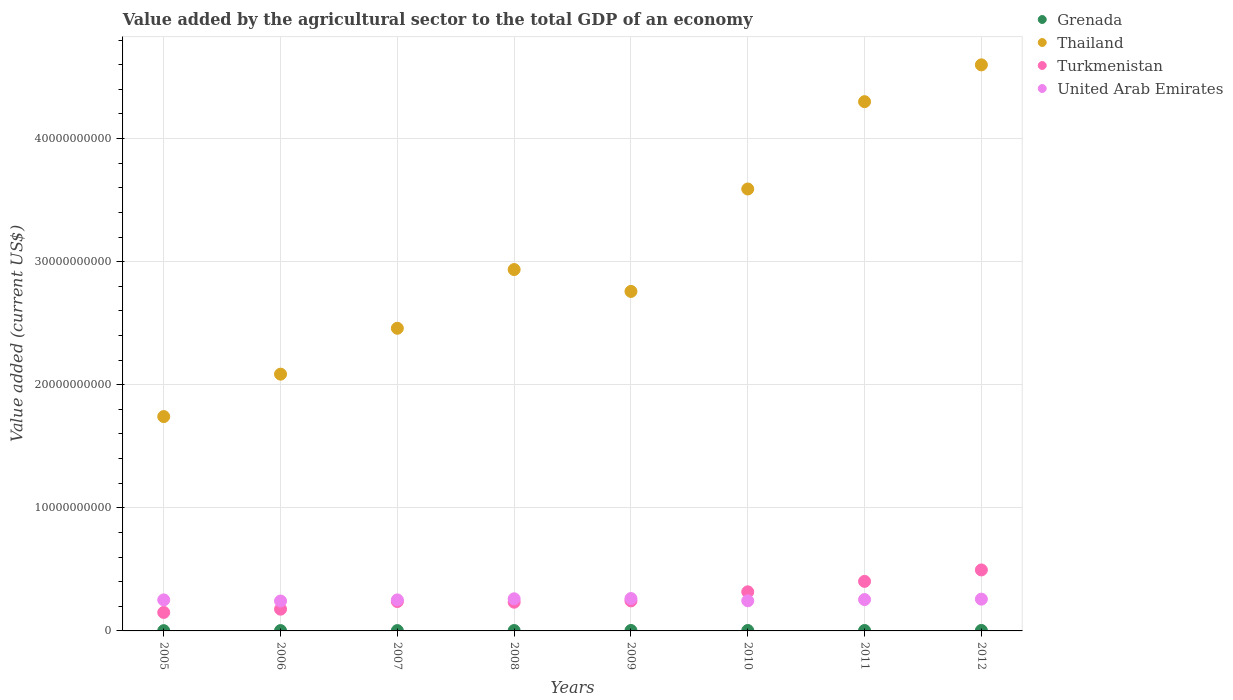How many different coloured dotlines are there?
Offer a terse response. 4. What is the value added by the agricultural sector to the total GDP in Turkmenistan in 2012?
Your answer should be compact. 4.95e+09. Across all years, what is the maximum value added by the agricultural sector to the total GDP in Thailand?
Offer a very short reply. 4.60e+1. Across all years, what is the minimum value added by the agricultural sector to the total GDP in Thailand?
Your answer should be very brief. 1.74e+1. In which year was the value added by the agricultural sector to the total GDP in Grenada minimum?
Make the answer very short. 2005. What is the total value added by the agricultural sector to the total GDP in Grenada in the graph?
Provide a short and direct response. 2.50e+08. What is the difference between the value added by the agricultural sector to the total GDP in Thailand in 2007 and that in 2010?
Give a very brief answer. -1.13e+1. What is the difference between the value added by the agricultural sector to the total GDP in United Arab Emirates in 2009 and the value added by the agricultural sector to the total GDP in Thailand in 2012?
Keep it short and to the point. -4.34e+1. What is the average value added by the agricultural sector to the total GDP in Grenada per year?
Ensure brevity in your answer.  3.12e+07. In the year 2008, what is the difference between the value added by the agricultural sector to the total GDP in Thailand and value added by the agricultural sector to the total GDP in Grenada?
Make the answer very short. 2.93e+1. In how many years, is the value added by the agricultural sector to the total GDP in Thailand greater than 16000000000 US$?
Your answer should be very brief. 8. What is the ratio of the value added by the agricultural sector to the total GDP in Thailand in 2006 to that in 2012?
Keep it short and to the point. 0.45. Is the value added by the agricultural sector to the total GDP in Turkmenistan in 2010 less than that in 2011?
Ensure brevity in your answer.  Yes. What is the difference between the highest and the second highest value added by the agricultural sector to the total GDP in Thailand?
Offer a very short reply. 2.99e+09. What is the difference between the highest and the lowest value added by the agricultural sector to the total GDP in United Arab Emirates?
Your response must be concise. 1.99e+08. In how many years, is the value added by the agricultural sector to the total GDP in Thailand greater than the average value added by the agricultural sector to the total GDP in Thailand taken over all years?
Provide a short and direct response. 3. Is it the case that in every year, the sum of the value added by the agricultural sector to the total GDP in Thailand and value added by the agricultural sector to the total GDP in Grenada  is greater than the value added by the agricultural sector to the total GDP in United Arab Emirates?
Give a very brief answer. Yes. Does the value added by the agricultural sector to the total GDP in United Arab Emirates monotonically increase over the years?
Your response must be concise. No. Is the value added by the agricultural sector to the total GDP in United Arab Emirates strictly less than the value added by the agricultural sector to the total GDP in Turkmenistan over the years?
Make the answer very short. No. How many dotlines are there?
Provide a short and direct response. 4. How many years are there in the graph?
Keep it short and to the point. 8. Are the values on the major ticks of Y-axis written in scientific E-notation?
Offer a very short reply. No. Does the graph contain any zero values?
Offer a very short reply. No. Where does the legend appear in the graph?
Provide a succinct answer. Top right. What is the title of the graph?
Your answer should be compact. Value added by the agricultural sector to the total GDP of an economy. Does "Tuvalu" appear as one of the legend labels in the graph?
Give a very brief answer. No. What is the label or title of the X-axis?
Ensure brevity in your answer.  Years. What is the label or title of the Y-axis?
Your answer should be very brief. Value added (current US$). What is the Value added (current US$) in Grenada in 2005?
Your answer should be very brief. 2.06e+07. What is the Value added (current US$) in Thailand in 2005?
Make the answer very short. 1.74e+1. What is the Value added (current US$) of Turkmenistan in 2005?
Your answer should be very brief. 1.50e+09. What is the Value added (current US$) in United Arab Emirates in 2005?
Keep it short and to the point. 2.52e+09. What is the Value added (current US$) of Grenada in 2006?
Make the answer very short. 2.72e+07. What is the Value added (current US$) in Thailand in 2006?
Make the answer very short. 2.09e+1. What is the Value added (current US$) of Turkmenistan in 2006?
Your answer should be very brief. 1.77e+09. What is the Value added (current US$) of United Arab Emirates in 2006?
Offer a very short reply. 2.43e+09. What is the Value added (current US$) of Grenada in 2007?
Your response must be concise. 2.70e+07. What is the Value added (current US$) in Thailand in 2007?
Ensure brevity in your answer.  2.46e+1. What is the Value added (current US$) in Turkmenistan in 2007?
Offer a very short reply. 2.39e+09. What is the Value added (current US$) of United Arab Emirates in 2007?
Make the answer very short. 2.52e+09. What is the Value added (current US$) in Grenada in 2008?
Offer a very short reply. 3.11e+07. What is the Value added (current US$) of Thailand in 2008?
Your answer should be very brief. 2.94e+1. What is the Value added (current US$) in Turkmenistan in 2008?
Give a very brief answer. 2.33e+09. What is the Value added (current US$) of United Arab Emirates in 2008?
Ensure brevity in your answer.  2.61e+09. What is the Value added (current US$) of Grenada in 2009?
Provide a short and direct response. 3.57e+07. What is the Value added (current US$) in Thailand in 2009?
Ensure brevity in your answer.  2.76e+1. What is the Value added (current US$) in Turkmenistan in 2009?
Provide a succinct answer. 2.44e+09. What is the Value added (current US$) of United Arab Emirates in 2009?
Your response must be concise. 2.63e+09. What is the Value added (current US$) of Grenada in 2010?
Ensure brevity in your answer.  3.48e+07. What is the Value added (current US$) in Thailand in 2010?
Make the answer very short. 3.59e+1. What is the Value added (current US$) in Turkmenistan in 2010?
Ensure brevity in your answer.  3.18e+09. What is the Value added (current US$) of United Arab Emirates in 2010?
Your answer should be compact. 2.45e+09. What is the Value added (current US$) in Grenada in 2011?
Ensure brevity in your answer.  3.46e+07. What is the Value added (current US$) in Thailand in 2011?
Keep it short and to the point. 4.30e+1. What is the Value added (current US$) of Turkmenistan in 2011?
Offer a terse response. 4.03e+09. What is the Value added (current US$) in United Arab Emirates in 2011?
Ensure brevity in your answer.  2.55e+09. What is the Value added (current US$) in Grenada in 2012?
Give a very brief answer. 3.87e+07. What is the Value added (current US$) of Thailand in 2012?
Provide a short and direct response. 4.60e+1. What is the Value added (current US$) of Turkmenistan in 2012?
Your answer should be very brief. 4.95e+09. What is the Value added (current US$) in United Arab Emirates in 2012?
Keep it short and to the point. 2.58e+09. Across all years, what is the maximum Value added (current US$) of Grenada?
Your response must be concise. 3.87e+07. Across all years, what is the maximum Value added (current US$) in Thailand?
Provide a succinct answer. 4.60e+1. Across all years, what is the maximum Value added (current US$) of Turkmenistan?
Keep it short and to the point. 4.95e+09. Across all years, what is the maximum Value added (current US$) of United Arab Emirates?
Offer a very short reply. 2.63e+09. Across all years, what is the minimum Value added (current US$) of Grenada?
Offer a terse response. 2.06e+07. Across all years, what is the minimum Value added (current US$) in Thailand?
Ensure brevity in your answer.  1.74e+1. Across all years, what is the minimum Value added (current US$) in Turkmenistan?
Offer a terse response. 1.50e+09. Across all years, what is the minimum Value added (current US$) in United Arab Emirates?
Keep it short and to the point. 2.43e+09. What is the total Value added (current US$) in Grenada in the graph?
Provide a succinct answer. 2.50e+08. What is the total Value added (current US$) of Thailand in the graph?
Make the answer very short. 2.45e+11. What is the total Value added (current US$) of Turkmenistan in the graph?
Your answer should be very brief. 2.26e+1. What is the total Value added (current US$) of United Arab Emirates in the graph?
Make the answer very short. 2.03e+1. What is the difference between the Value added (current US$) of Grenada in 2005 and that in 2006?
Give a very brief answer. -6.57e+06. What is the difference between the Value added (current US$) of Thailand in 2005 and that in 2006?
Offer a very short reply. -3.45e+09. What is the difference between the Value added (current US$) in Turkmenistan in 2005 and that in 2006?
Make the answer very short. -2.66e+08. What is the difference between the Value added (current US$) of United Arab Emirates in 2005 and that in 2006?
Provide a succinct answer. 8.99e+07. What is the difference between the Value added (current US$) of Grenada in 2005 and that in 2007?
Your answer should be very brief. -6.37e+06. What is the difference between the Value added (current US$) in Thailand in 2005 and that in 2007?
Offer a very short reply. -7.17e+09. What is the difference between the Value added (current US$) in Turkmenistan in 2005 and that in 2007?
Offer a very short reply. -8.86e+08. What is the difference between the Value added (current US$) in United Arab Emirates in 2005 and that in 2007?
Give a very brief answer. 1.36e+06. What is the difference between the Value added (current US$) of Grenada in 2005 and that in 2008?
Make the answer very short. -1.05e+07. What is the difference between the Value added (current US$) of Thailand in 2005 and that in 2008?
Your answer should be compact. -1.19e+1. What is the difference between the Value added (current US$) in Turkmenistan in 2005 and that in 2008?
Give a very brief answer. -8.31e+08. What is the difference between the Value added (current US$) in United Arab Emirates in 2005 and that in 2008?
Your answer should be compact. -8.96e+07. What is the difference between the Value added (current US$) in Grenada in 2005 and that in 2009?
Your response must be concise. -1.51e+07. What is the difference between the Value added (current US$) of Thailand in 2005 and that in 2009?
Ensure brevity in your answer.  -1.02e+1. What is the difference between the Value added (current US$) in Turkmenistan in 2005 and that in 2009?
Provide a short and direct response. -9.38e+08. What is the difference between the Value added (current US$) of United Arab Emirates in 2005 and that in 2009?
Offer a very short reply. -1.09e+08. What is the difference between the Value added (current US$) in Grenada in 2005 and that in 2010?
Give a very brief answer. -1.42e+07. What is the difference between the Value added (current US$) in Thailand in 2005 and that in 2010?
Ensure brevity in your answer.  -1.85e+1. What is the difference between the Value added (current US$) of Turkmenistan in 2005 and that in 2010?
Give a very brief answer. -1.67e+09. What is the difference between the Value added (current US$) in United Arab Emirates in 2005 and that in 2010?
Your answer should be very brief. 7.19e+07. What is the difference between the Value added (current US$) of Grenada in 2005 and that in 2011?
Provide a succinct answer. -1.40e+07. What is the difference between the Value added (current US$) in Thailand in 2005 and that in 2011?
Keep it short and to the point. -2.56e+1. What is the difference between the Value added (current US$) of Turkmenistan in 2005 and that in 2011?
Make the answer very short. -2.52e+09. What is the difference between the Value added (current US$) in United Arab Emirates in 2005 and that in 2011?
Your response must be concise. -2.67e+07. What is the difference between the Value added (current US$) in Grenada in 2005 and that in 2012?
Ensure brevity in your answer.  -1.80e+07. What is the difference between the Value added (current US$) in Thailand in 2005 and that in 2012?
Provide a succinct answer. -2.86e+1. What is the difference between the Value added (current US$) in Turkmenistan in 2005 and that in 2012?
Provide a succinct answer. -3.45e+09. What is the difference between the Value added (current US$) in United Arab Emirates in 2005 and that in 2012?
Provide a short and direct response. -6.18e+07. What is the difference between the Value added (current US$) of Grenada in 2006 and that in 2007?
Offer a terse response. 1.96e+05. What is the difference between the Value added (current US$) of Thailand in 2006 and that in 2007?
Give a very brief answer. -3.73e+09. What is the difference between the Value added (current US$) of Turkmenistan in 2006 and that in 2007?
Provide a short and direct response. -6.20e+08. What is the difference between the Value added (current US$) of United Arab Emirates in 2006 and that in 2007?
Keep it short and to the point. -8.85e+07. What is the difference between the Value added (current US$) in Grenada in 2006 and that in 2008?
Provide a short and direct response. -3.93e+06. What is the difference between the Value added (current US$) in Thailand in 2006 and that in 2008?
Your response must be concise. -8.50e+09. What is the difference between the Value added (current US$) in Turkmenistan in 2006 and that in 2008?
Offer a terse response. -5.66e+08. What is the difference between the Value added (current US$) of United Arab Emirates in 2006 and that in 2008?
Your answer should be very brief. -1.79e+08. What is the difference between the Value added (current US$) of Grenada in 2006 and that in 2009?
Your response must be concise. -8.50e+06. What is the difference between the Value added (current US$) in Thailand in 2006 and that in 2009?
Your response must be concise. -6.72e+09. What is the difference between the Value added (current US$) in Turkmenistan in 2006 and that in 2009?
Your answer should be compact. -6.72e+08. What is the difference between the Value added (current US$) of United Arab Emirates in 2006 and that in 2009?
Provide a short and direct response. -1.99e+08. What is the difference between the Value added (current US$) of Grenada in 2006 and that in 2010?
Offer a terse response. -7.61e+06. What is the difference between the Value added (current US$) in Thailand in 2006 and that in 2010?
Your answer should be very brief. -1.50e+1. What is the difference between the Value added (current US$) in Turkmenistan in 2006 and that in 2010?
Offer a terse response. -1.41e+09. What is the difference between the Value added (current US$) in United Arab Emirates in 2006 and that in 2010?
Make the answer very short. -1.80e+07. What is the difference between the Value added (current US$) in Grenada in 2006 and that in 2011?
Make the answer very short. -7.45e+06. What is the difference between the Value added (current US$) of Thailand in 2006 and that in 2011?
Make the answer very short. -2.21e+1. What is the difference between the Value added (current US$) of Turkmenistan in 2006 and that in 2011?
Your answer should be very brief. -2.26e+09. What is the difference between the Value added (current US$) in United Arab Emirates in 2006 and that in 2011?
Ensure brevity in your answer.  -1.17e+08. What is the difference between the Value added (current US$) in Grenada in 2006 and that in 2012?
Offer a terse response. -1.15e+07. What is the difference between the Value added (current US$) in Thailand in 2006 and that in 2012?
Offer a terse response. -2.51e+1. What is the difference between the Value added (current US$) in Turkmenistan in 2006 and that in 2012?
Provide a succinct answer. -3.19e+09. What is the difference between the Value added (current US$) in United Arab Emirates in 2006 and that in 2012?
Provide a succinct answer. -1.52e+08. What is the difference between the Value added (current US$) in Grenada in 2007 and that in 2008?
Provide a succinct answer. -4.13e+06. What is the difference between the Value added (current US$) of Thailand in 2007 and that in 2008?
Ensure brevity in your answer.  -4.77e+09. What is the difference between the Value added (current US$) in Turkmenistan in 2007 and that in 2008?
Your response must be concise. 5.48e+07. What is the difference between the Value added (current US$) of United Arab Emirates in 2007 and that in 2008?
Make the answer very short. -9.09e+07. What is the difference between the Value added (current US$) of Grenada in 2007 and that in 2009?
Keep it short and to the point. -8.70e+06. What is the difference between the Value added (current US$) of Thailand in 2007 and that in 2009?
Offer a very short reply. -2.99e+09. What is the difference between the Value added (current US$) in Turkmenistan in 2007 and that in 2009?
Provide a succinct answer. -5.19e+07. What is the difference between the Value added (current US$) in United Arab Emirates in 2007 and that in 2009?
Give a very brief answer. -1.10e+08. What is the difference between the Value added (current US$) in Grenada in 2007 and that in 2010?
Your answer should be compact. -7.81e+06. What is the difference between the Value added (current US$) of Thailand in 2007 and that in 2010?
Offer a very short reply. -1.13e+1. What is the difference between the Value added (current US$) of Turkmenistan in 2007 and that in 2010?
Offer a very short reply. -7.89e+08. What is the difference between the Value added (current US$) in United Arab Emirates in 2007 and that in 2010?
Give a very brief answer. 7.05e+07. What is the difference between the Value added (current US$) in Grenada in 2007 and that in 2011?
Your answer should be very brief. -7.65e+06. What is the difference between the Value added (current US$) of Thailand in 2007 and that in 2011?
Ensure brevity in your answer.  -1.84e+1. What is the difference between the Value added (current US$) of Turkmenistan in 2007 and that in 2011?
Offer a very short reply. -1.64e+09. What is the difference between the Value added (current US$) of United Arab Emirates in 2007 and that in 2011?
Provide a short and direct response. -2.80e+07. What is the difference between the Value added (current US$) of Grenada in 2007 and that in 2012?
Your answer should be very brief. -1.17e+07. What is the difference between the Value added (current US$) of Thailand in 2007 and that in 2012?
Give a very brief answer. -2.14e+1. What is the difference between the Value added (current US$) of Turkmenistan in 2007 and that in 2012?
Keep it short and to the point. -2.57e+09. What is the difference between the Value added (current US$) of United Arab Emirates in 2007 and that in 2012?
Give a very brief answer. -6.32e+07. What is the difference between the Value added (current US$) of Grenada in 2008 and that in 2009?
Make the answer very short. -4.57e+06. What is the difference between the Value added (current US$) of Thailand in 2008 and that in 2009?
Offer a very short reply. 1.78e+09. What is the difference between the Value added (current US$) in Turkmenistan in 2008 and that in 2009?
Make the answer very short. -1.07e+08. What is the difference between the Value added (current US$) of United Arab Emirates in 2008 and that in 2009?
Ensure brevity in your answer.  -1.91e+07. What is the difference between the Value added (current US$) in Grenada in 2008 and that in 2010?
Your answer should be very brief. -3.68e+06. What is the difference between the Value added (current US$) of Thailand in 2008 and that in 2010?
Give a very brief answer. -6.54e+09. What is the difference between the Value added (current US$) of Turkmenistan in 2008 and that in 2010?
Your response must be concise. -8.44e+08. What is the difference between the Value added (current US$) in United Arab Emirates in 2008 and that in 2010?
Your answer should be very brief. 1.61e+08. What is the difference between the Value added (current US$) in Grenada in 2008 and that in 2011?
Keep it short and to the point. -3.52e+06. What is the difference between the Value added (current US$) in Thailand in 2008 and that in 2011?
Offer a very short reply. -1.36e+1. What is the difference between the Value added (current US$) in Turkmenistan in 2008 and that in 2011?
Provide a succinct answer. -1.69e+09. What is the difference between the Value added (current US$) of United Arab Emirates in 2008 and that in 2011?
Your answer should be compact. 6.29e+07. What is the difference between the Value added (current US$) in Grenada in 2008 and that in 2012?
Ensure brevity in your answer.  -7.53e+06. What is the difference between the Value added (current US$) of Thailand in 2008 and that in 2012?
Your response must be concise. -1.66e+1. What is the difference between the Value added (current US$) of Turkmenistan in 2008 and that in 2012?
Ensure brevity in your answer.  -2.62e+09. What is the difference between the Value added (current US$) in United Arab Emirates in 2008 and that in 2012?
Offer a terse response. 2.78e+07. What is the difference between the Value added (current US$) of Grenada in 2009 and that in 2010?
Your response must be concise. 8.85e+05. What is the difference between the Value added (current US$) in Thailand in 2009 and that in 2010?
Offer a very short reply. -8.32e+09. What is the difference between the Value added (current US$) in Turkmenistan in 2009 and that in 2010?
Give a very brief answer. -7.37e+08. What is the difference between the Value added (current US$) of United Arab Emirates in 2009 and that in 2010?
Your answer should be compact. 1.81e+08. What is the difference between the Value added (current US$) in Grenada in 2009 and that in 2011?
Your answer should be compact. 1.05e+06. What is the difference between the Value added (current US$) of Thailand in 2009 and that in 2011?
Provide a succinct answer. -1.54e+1. What is the difference between the Value added (current US$) of Turkmenistan in 2009 and that in 2011?
Your response must be concise. -1.59e+09. What is the difference between the Value added (current US$) in United Arab Emirates in 2009 and that in 2011?
Your answer should be very brief. 8.20e+07. What is the difference between the Value added (current US$) in Grenada in 2009 and that in 2012?
Offer a very short reply. -2.97e+06. What is the difference between the Value added (current US$) in Thailand in 2009 and that in 2012?
Give a very brief answer. -1.84e+1. What is the difference between the Value added (current US$) in Turkmenistan in 2009 and that in 2012?
Make the answer very short. -2.51e+09. What is the difference between the Value added (current US$) in United Arab Emirates in 2009 and that in 2012?
Provide a succinct answer. 4.68e+07. What is the difference between the Value added (current US$) of Grenada in 2010 and that in 2011?
Give a very brief answer. 1.64e+05. What is the difference between the Value added (current US$) of Thailand in 2010 and that in 2011?
Offer a terse response. -7.09e+09. What is the difference between the Value added (current US$) in Turkmenistan in 2010 and that in 2011?
Provide a succinct answer. -8.48e+08. What is the difference between the Value added (current US$) of United Arab Emirates in 2010 and that in 2011?
Provide a succinct answer. -9.86e+07. What is the difference between the Value added (current US$) of Grenada in 2010 and that in 2012?
Ensure brevity in your answer.  -3.85e+06. What is the difference between the Value added (current US$) in Thailand in 2010 and that in 2012?
Your answer should be compact. -1.01e+1. What is the difference between the Value added (current US$) of Turkmenistan in 2010 and that in 2012?
Offer a terse response. -1.78e+09. What is the difference between the Value added (current US$) of United Arab Emirates in 2010 and that in 2012?
Offer a very short reply. -1.34e+08. What is the difference between the Value added (current US$) in Grenada in 2011 and that in 2012?
Offer a terse response. -4.02e+06. What is the difference between the Value added (current US$) of Thailand in 2011 and that in 2012?
Provide a short and direct response. -2.99e+09. What is the difference between the Value added (current US$) of Turkmenistan in 2011 and that in 2012?
Your answer should be compact. -9.29e+08. What is the difference between the Value added (current US$) of United Arab Emirates in 2011 and that in 2012?
Give a very brief answer. -3.51e+07. What is the difference between the Value added (current US$) in Grenada in 2005 and the Value added (current US$) in Thailand in 2006?
Provide a short and direct response. -2.08e+1. What is the difference between the Value added (current US$) in Grenada in 2005 and the Value added (current US$) in Turkmenistan in 2006?
Provide a succinct answer. -1.75e+09. What is the difference between the Value added (current US$) of Grenada in 2005 and the Value added (current US$) of United Arab Emirates in 2006?
Your answer should be very brief. -2.41e+09. What is the difference between the Value added (current US$) of Thailand in 2005 and the Value added (current US$) of Turkmenistan in 2006?
Your answer should be compact. 1.56e+1. What is the difference between the Value added (current US$) in Thailand in 2005 and the Value added (current US$) in United Arab Emirates in 2006?
Your answer should be very brief. 1.50e+1. What is the difference between the Value added (current US$) of Turkmenistan in 2005 and the Value added (current US$) of United Arab Emirates in 2006?
Give a very brief answer. -9.29e+08. What is the difference between the Value added (current US$) in Grenada in 2005 and the Value added (current US$) in Thailand in 2007?
Your answer should be compact. -2.46e+1. What is the difference between the Value added (current US$) in Grenada in 2005 and the Value added (current US$) in Turkmenistan in 2007?
Your answer should be very brief. -2.37e+09. What is the difference between the Value added (current US$) in Grenada in 2005 and the Value added (current US$) in United Arab Emirates in 2007?
Give a very brief answer. -2.50e+09. What is the difference between the Value added (current US$) of Thailand in 2005 and the Value added (current US$) of Turkmenistan in 2007?
Offer a terse response. 1.50e+1. What is the difference between the Value added (current US$) in Thailand in 2005 and the Value added (current US$) in United Arab Emirates in 2007?
Ensure brevity in your answer.  1.49e+1. What is the difference between the Value added (current US$) of Turkmenistan in 2005 and the Value added (current US$) of United Arab Emirates in 2007?
Make the answer very short. -1.02e+09. What is the difference between the Value added (current US$) in Grenada in 2005 and the Value added (current US$) in Thailand in 2008?
Your response must be concise. -2.93e+1. What is the difference between the Value added (current US$) in Grenada in 2005 and the Value added (current US$) in Turkmenistan in 2008?
Offer a terse response. -2.31e+09. What is the difference between the Value added (current US$) in Grenada in 2005 and the Value added (current US$) in United Arab Emirates in 2008?
Provide a short and direct response. -2.59e+09. What is the difference between the Value added (current US$) of Thailand in 2005 and the Value added (current US$) of Turkmenistan in 2008?
Ensure brevity in your answer.  1.51e+1. What is the difference between the Value added (current US$) of Thailand in 2005 and the Value added (current US$) of United Arab Emirates in 2008?
Make the answer very short. 1.48e+1. What is the difference between the Value added (current US$) in Turkmenistan in 2005 and the Value added (current US$) in United Arab Emirates in 2008?
Provide a short and direct response. -1.11e+09. What is the difference between the Value added (current US$) of Grenada in 2005 and the Value added (current US$) of Thailand in 2009?
Make the answer very short. -2.76e+1. What is the difference between the Value added (current US$) in Grenada in 2005 and the Value added (current US$) in Turkmenistan in 2009?
Your answer should be very brief. -2.42e+09. What is the difference between the Value added (current US$) in Grenada in 2005 and the Value added (current US$) in United Arab Emirates in 2009?
Provide a succinct answer. -2.61e+09. What is the difference between the Value added (current US$) in Thailand in 2005 and the Value added (current US$) in Turkmenistan in 2009?
Your answer should be compact. 1.50e+1. What is the difference between the Value added (current US$) of Thailand in 2005 and the Value added (current US$) of United Arab Emirates in 2009?
Provide a succinct answer. 1.48e+1. What is the difference between the Value added (current US$) in Turkmenistan in 2005 and the Value added (current US$) in United Arab Emirates in 2009?
Offer a very short reply. -1.13e+09. What is the difference between the Value added (current US$) of Grenada in 2005 and the Value added (current US$) of Thailand in 2010?
Make the answer very short. -3.59e+1. What is the difference between the Value added (current US$) of Grenada in 2005 and the Value added (current US$) of Turkmenistan in 2010?
Provide a succinct answer. -3.16e+09. What is the difference between the Value added (current US$) of Grenada in 2005 and the Value added (current US$) of United Arab Emirates in 2010?
Give a very brief answer. -2.43e+09. What is the difference between the Value added (current US$) in Thailand in 2005 and the Value added (current US$) in Turkmenistan in 2010?
Your answer should be very brief. 1.42e+1. What is the difference between the Value added (current US$) in Thailand in 2005 and the Value added (current US$) in United Arab Emirates in 2010?
Keep it short and to the point. 1.50e+1. What is the difference between the Value added (current US$) of Turkmenistan in 2005 and the Value added (current US$) of United Arab Emirates in 2010?
Offer a very short reply. -9.47e+08. What is the difference between the Value added (current US$) in Grenada in 2005 and the Value added (current US$) in Thailand in 2011?
Provide a succinct answer. -4.30e+1. What is the difference between the Value added (current US$) of Grenada in 2005 and the Value added (current US$) of Turkmenistan in 2011?
Your answer should be very brief. -4.00e+09. What is the difference between the Value added (current US$) in Grenada in 2005 and the Value added (current US$) in United Arab Emirates in 2011?
Provide a short and direct response. -2.53e+09. What is the difference between the Value added (current US$) in Thailand in 2005 and the Value added (current US$) in Turkmenistan in 2011?
Offer a very short reply. 1.34e+1. What is the difference between the Value added (current US$) of Thailand in 2005 and the Value added (current US$) of United Arab Emirates in 2011?
Make the answer very short. 1.49e+1. What is the difference between the Value added (current US$) of Turkmenistan in 2005 and the Value added (current US$) of United Arab Emirates in 2011?
Your response must be concise. -1.05e+09. What is the difference between the Value added (current US$) of Grenada in 2005 and the Value added (current US$) of Thailand in 2012?
Provide a short and direct response. -4.60e+1. What is the difference between the Value added (current US$) of Grenada in 2005 and the Value added (current US$) of Turkmenistan in 2012?
Provide a succinct answer. -4.93e+09. What is the difference between the Value added (current US$) of Grenada in 2005 and the Value added (current US$) of United Arab Emirates in 2012?
Your answer should be very brief. -2.56e+09. What is the difference between the Value added (current US$) of Thailand in 2005 and the Value added (current US$) of Turkmenistan in 2012?
Your answer should be compact. 1.25e+1. What is the difference between the Value added (current US$) in Thailand in 2005 and the Value added (current US$) in United Arab Emirates in 2012?
Give a very brief answer. 1.48e+1. What is the difference between the Value added (current US$) of Turkmenistan in 2005 and the Value added (current US$) of United Arab Emirates in 2012?
Ensure brevity in your answer.  -1.08e+09. What is the difference between the Value added (current US$) of Grenada in 2006 and the Value added (current US$) of Thailand in 2007?
Your answer should be very brief. -2.46e+1. What is the difference between the Value added (current US$) in Grenada in 2006 and the Value added (current US$) in Turkmenistan in 2007?
Offer a terse response. -2.36e+09. What is the difference between the Value added (current US$) of Grenada in 2006 and the Value added (current US$) of United Arab Emirates in 2007?
Offer a terse response. -2.49e+09. What is the difference between the Value added (current US$) of Thailand in 2006 and the Value added (current US$) of Turkmenistan in 2007?
Give a very brief answer. 1.85e+1. What is the difference between the Value added (current US$) in Thailand in 2006 and the Value added (current US$) in United Arab Emirates in 2007?
Provide a short and direct response. 1.83e+1. What is the difference between the Value added (current US$) of Turkmenistan in 2006 and the Value added (current US$) of United Arab Emirates in 2007?
Make the answer very short. -7.52e+08. What is the difference between the Value added (current US$) of Grenada in 2006 and the Value added (current US$) of Thailand in 2008?
Offer a terse response. -2.93e+1. What is the difference between the Value added (current US$) of Grenada in 2006 and the Value added (current US$) of Turkmenistan in 2008?
Ensure brevity in your answer.  -2.31e+09. What is the difference between the Value added (current US$) in Grenada in 2006 and the Value added (current US$) in United Arab Emirates in 2008?
Give a very brief answer. -2.58e+09. What is the difference between the Value added (current US$) in Thailand in 2006 and the Value added (current US$) in Turkmenistan in 2008?
Provide a short and direct response. 1.85e+1. What is the difference between the Value added (current US$) in Thailand in 2006 and the Value added (current US$) in United Arab Emirates in 2008?
Provide a succinct answer. 1.82e+1. What is the difference between the Value added (current US$) in Turkmenistan in 2006 and the Value added (current US$) in United Arab Emirates in 2008?
Provide a succinct answer. -8.43e+08. What is the difference between the Value added (current US$) of Grenada in 2006 and the Value added (current US$) of Thailand in 2009?
Offer a terse response. -2.76e+1. What is the difference between the Value added (current US$) in Grenada in 2006 and the Value added (current US$) in Turkmenistan in 2009?
Ensure brevity in your answer.  -2.41e+09. What is the difference between the Value added (current US$) of Grenada in 2006 and the Value added (current US$) of United Arab Emirates in 2009?
Make the answer very short. -2.60e+09. What is the difference between the Value added (current US$) of Thailand in 2006 and the Value added (current US$) of Turkmenistan in 2009?
Give a very brief answer. 1.84e+1. What is the difference between the Value added (current US$) in Thailand in 2006 and the Value added (current US$) in United Arab Emirates in 2009?
Offer a very short reply. 1.82e+1. What is the difference between the Value added (current US$) in Turkmenistan in 2006 and the Value added (current US$) in United Arab Emirates in 2009?
Keep it short and to the point. -8.62e+08. What is the difference between the Value added (current US$) of Grenada in 2006 and the Value added (current US$) of Thailand in 2010?
Provide a short and direct response. -3.59e+1. What is the difference between the Value added (current US$) in Grenada in 2006 and the Value added (current US$) in Turkmenistan in 2010?
Your answer should be very brief. -3.15e+09. What is the difference between the Value added (current US$) of Grenada in 2006 and the Value added (current US$) of United Arab Emirates in 2010?
Offer a terse response. -2.42e+09. What is the difference between the Value added (current US$) in Thailand in 2006 and the Value added (current US$) in Turkmenistan in 2010?
Your answer should be very brief. 1.77e+1. What is the difference between the Value added (current US$) in Thailand in 2006 and the Value added (current US$) in United Arab Emirates in 2010?
Keep it short and to the point. 1.84e+1. What is the difference between the Value added (current US$) of Turkmenistan in 2006 and the Value added (current US$) of United Arab Emirates in 2010?
Ensure brevity in your answer.  -6.81e+08. What is the difference between the Value added (current US$) in Grenada in 2006 and the Value added (current US$) in Thailand in 2011?
Your answer should be very brief. -4.30e+1. What is the difference between the Value added (current US$) of Grenada in 2006 and the Value added (current US$) of Turkmenistan in 2011?
Keep it short and to the point. -4.00e+09. What is the difference between the Value added (current US$) in Grenada in 2006 and the Value added (current US$) in United Arab Emirates in 2011?
Offer a very short reply. -2.52e+09. What is the difference between the Value added (current US$) of Thailand in 2006 and the Value added (current US$) of Turkmenistan in 2011?
Ensure brevity in your answer.  1.68e+1. What is the difference between the Value added (current US$) of Thailand in 2006 and the Value added (current US$) of United Arab Emirates in 2011?
Provide a succinct answer. 1.83e+1. What is the difference between the Value added (current US$) of Turkmenistan in 2006 and the Value added (current US$) of United Arab Emirates in 2011?
Keep it short and to the point. -7.80e+08. What is the difference between the Value added (current US$) in Grenada in 2006 and the Value added (current US$) in Thailand in 2012?
Provide a short and direct response. -4.60e+1. What is the difference between the Value added (current US$) in Grenada in 2006 and the Value added (current US$) in Turkmenistan in 2012?
Provide a succinct answer. -4.93e+09. What is the difference between the Value added (current US$) of Grenada in 2006 and the Value added (current US$) of United Arab Emirates in 2012?
Provide a short and direct response. -2.55e+09. What is the difference between the Value added (current US$) in Thailand in 2006 and the Value added (current US$) in Turkmenistan in 2012?
Give a very brief answer. 1.59e+1. What is the difference between the Value added (current US$) of Thailand in 2006 and the Value added (current US$) of United Arab Emirates in 2012?
Keep it short and to the point. 1.83e+1. What is the difference between the Value added (current US$) of Turkmenistan in 2006 and the Value added (current US$) of United Arab Emirates in 2012?
Offer a terse response. -8.15e+08. What is the difference between the Value added (current US$) in Grenada in 2007 and the Value added (current US$) in Thailand in 2008?
Provide a succinct answer. -2.93e+1. What is the difference between the Value added (current US$) in Grenada in 2007 and the Value added (current US$) in Turkmenistan in 2008?
Provide a succinct answer. -2.31e+09. What is the difference between the Value added (current US$) in Grenada in 2007 and the Value added (current US$) in United Arab Emirates in 2008?
Offer a terse response. -2.58e+09. What is the difference between the Value added (current US$) in Thailand in 2007 and the Value added (current US$) in Turkmenistan in 2008?
Your answer should be very brief. 2.23e+1. What is the difference between the Value added (current US$) in Thailand in 2007 and the Value added (current US$) in United Arab Emirates in 2008?
Give a very brief answer. 2.20e+1. What is the difference between the Value added (current US$) of Turkmenistan in 2007 and the Value added (current US$) of United Arab Emirates in 2008?
Make the answer very short. -2.22e+08. What is the difference between the Value added (current US$) in Grenada in 2007 and the Value added (current US$) in Thailand in 2009?
Provide a succinct answer. -2.76e+1. What is the difference between the Value added (current US$) of Grenada in 2007 and the Value added (current US$) of Turkmenistan in 2009?
Your response must be concise. -2.41e+09. What is the difference between the Value added (current US$) of Grenada in 2007 and the Value added (current US$) of United Arab Emirates in 2009?
Provide a short and direct response. -2.60e+09. What is the difference between the Value added (current US$) of Thailand in 2007 and the Value added (current US$) of Turkmenistan in 2009?
Offer a terse response. 2.21e+1. What is the difference between the Value added (current US$) of Thailand in 2007 and the Value added (current US$) of United Arab Emirates in 2009?
Your answer should be very brief. 2.20e+1. What is the difference between the Value added (current US$) in Turkmenistan in 2007 and the Value added (current US$) in United Arab Emirates in 2009?
Offer a terse response. -2.41e+08. What is the difference between the Value added (current US$) of Grenada in 2007 and the Value added (current US$) of Thailand in 2010?
Offer a terse response. -3.59e+1. What is the difference between the Value added (current US$) of Grenada in 2007 and the Value added (current US$) of Turkmenistan in 2010?
Provide a short and direct response. -3.15e+09. What is the difference between the Value added (current US$) of Grenada in 2007 and the Value added (current US$) of United Arab Emirates in 2010?
Provide a short and direct response. -2.42e+09. What is the difference between the Value added (current US$) of Thailand in 2007 and the Value added (current US$) of Turkmenistan in 2010?
Give a very brief answer. 2.14e+1. What is the difference between the Value added (current US$) in Thailand in 2007 and the Value added (current US$) in United Arab Emirates in 2010?
Keep it short and to the point. 2.21e+1. What is the difference between the Value added (current US$) of Turkmenistan in 2007 and the Value added (current US$) of United Arab Emirates in 2010?
Provide a short and direct response. -6.07e+07. What is the difference between the Value added (current US$) of Grenada in 2007 and the Value added (current US$) of Thailand in 2011?
Your answer should be very brief. -4.30e+1. What is the difference between the Value added (current US$) in Grenada in 2007 and the Value added (current US$) in Turkmenistan in 2011?
Give a very brief answer. -4.00e+09. What is the difference between the Value added (current US$) of Grenada in 2007 and the Value added (current US$) of United Arab Emirates in 2011?
Provide a succinct answer. -2.52e+09. What is the difference between the Value added (current US$) in Thailand in 2007 and the Value added (current US$) in Turkmenistan in 2011?
Make the answer very short. 2.06e+1. What is the difference between the Value added (current US$) of Thailand in 2007 and the Value added (current US$) of United Arab Emirates in 2011?
Provide a succinct answer. 2.20e+1. What is the difference between the Value added (current US$) in Turkmenistan in 2007 and the Value added (current US$) in United Arab Emirates in 2011?
Ensure brevity in your answer.  -1.59e+08. What is the difference between the Value added (current US$) of Grenada in 2007 and the Value added (current US$) of Thailand in 2012?
Ensure brevity in your answer.  -4.60e+1. What is the difference between the Value added (current US$) in Grenada in 2007 and the Value added (current US$) in Turkmenistan in 2012?
Your answer should be compact. -4.93e+09. What is the difference between the Value added (current US$) of Grenada in 2007 and the Value added (current US$) of United Arab Emirates in 2012?
Keep it short and to the point. -2.56e+09. What is the difference between the Value added (current US$) of Thailand in 2007 and the Value added (current US$) of Turkmenistan in 2012?
Offer a terse response. 1.96e+1. What is the difference between the Value added (current US$) in Thailand in 2007 and the Value added (current US$) in United Arab Emirates in 2012?
Keep it short and to the point. 2.20e+1. What is the difference between the Value added (current US$) of Turkmenistan in 2007 and the Value added (current US$) of United Arab Emirates in 2012?
Give a very brief answer. -1.94e+08. What is the difference between the Value added (current US$) of Grenada in 2008 and the Value added (current US$) of Thailand in 2009?
Make the answer very short. -2.75e+1. What is the difference between the Value added (current US$) in Grenada in 2008 and the Value added (current US$) in Turkmenistan in 2009?
Offer a terse response. -2.41e+09. What is the difference between the Value added (current US$) of Grenada in 2008 and the Value added (current US$) of United Arab Emirates in 2009?
Give a very brief answer. -2.60e+09. What is the difference between the Value added (current US$) of Thailand in 2008 and the Value added (current US$) of Turkmenistan in 2009?
Offer a very short reply. 2.69e+1. What is the difference between the Value added (current US$) of Thailand in 2008 and the Value added (current US$) of United Arab Emirates in 2009?
Give a very brief answer. 2.67e+1. What is the difference between the Value added (current US$) of Turkmenistan in 2008 and the Value added (current US$) of United Arab Emirates in 2009?
Your response must be concise. -2.96e+08. What is the difference between the Value added (current US$) of Grenada in 2008 and the Value added (current US$) of Thailand in 2010?
Make the answer very short. -3.59e+1. What is the difference between the Value added (current US$) of Grenada in 2008 and the Value added (current US$) of Turkmenistan in 2010?
Offer a terse response. -3.15e+09. What is the difference between the Value added (current US$) in Grenada in 2008 and the Value added (current US$) in United Arab Emirates in 2010?
Offer a very short reply. -2.42e+09. What is the difference between the Value added (current US$) of Thailand in 2008 and the Value added (current US$) of Turkmenistan in 2010?
Provide a succinct answer. 2.62e+1. What is the difference between the Value added (current US$) in Thailand in 2008 and the Value added (current US$) in United Arab Emirates in 2010?
Provide a short and direct response. 2.69e+1. What is the difference between the Value added (current US$) in Turkmenistan in 2008 and the Value added (current US$) in United Arab Emirates in 2010?
Ensure brevity in your answer.  -1.15e+08. What is the difference between the Value added (current US$) of Grenada in 2008 and the Value added (current US$) of Thailand in 2011?
Make the answer very short. -4.30e+1. What is the difference between the Value added (current US$) of Grenada in 2008 and the Value added (current US$) of Turkmenistan in 2011?
Your answer should be very brief. -3.99e+09. What is the difference between the Value added (current US$) in Grenada in 2008 and the Value added (current US$) in United Arab Emirates in 2011?
Keep it short and to the point. -2.52e+09. What is the difference between the Value added (current US$) of Thailand in 2008 and the Value added (current US$) of Turkmenistan in 2011?
Offer a terse response. 2.53e+1. What is the difference between the Value added (current US$) in Thailand in 2008 and the Value added (current US$) in United Arab Emirates in 2011?
Your answer should be compact. 2.68e+1. What is the difference between the Value added (current US$) of Turkmenistan in 2008 and the Value added (current US$) of United Arab Emirates in 2011?
Your answer should be compact. -2.14e+08. What is the difference between the Value added (current US$) of Grenada in 2008 and the Value added (current US$) of Thailand in 2012?
Give a very brief answer. -4.60e+1. What is the difference between the Value added (current US$) of Grenada in 2008 and the Value added (current US$) of Turkmenistan in 2012?
Offer a terse response. -4.92e+09. What is the difference between the Value added (current US$) in Grenada in 2008 and the Value added (current US$) in United Arab Emirates in 2012?
Give a very brief answer. -2.55e+09. What is the difference between the Value added (current US$) of Thailand in 2008 and the Value added (current US$) of Turkmenistan in 2012?
Make the answer very short. 2.44e+1. What is the difference between the Value added (current US$) in Thailand in 2008 and the Value added (current US$) in United Arab Emirates in 2012?
Provide a short and direct response. 2.68e+1. What is the difference between the Value added (current US$) of Turkmenistan in 2008 and the Value added (current US$) of United Arab Emirates in 2012?
Provide a succinct answer. -2.49e+08. What is the difference between the Value added (current US$) of Grenada in 2009 and the Value added (current US$) of Thailand in 2010?
Your answer should be compact. -3.59e+1. What is the difference between the Value added (current US$) in Grenada in 2009 and the Value added (current US$) in Turkmenistan in 2010?
Provide a short and direct response. -3.14e+09. What is the difference between the Value added (current US$) in Grenada in 2009 and the Value added (current US$) in United Arab Emirates in 2010?
Your answer should be compact. -2.41e+09. What is the difference between the Value added (current US$) of Thailand in 2009 and the Value added (current US$) of Turkmenistan in 2010?
Make the answer very short. 2.44e+1. What is the difference between the Value added (current US$) of Thailand in 2009 and the Value added (current US$) of United Arab Emirates in 2010?
Your answer should be very brief. 2.51e+1. What is the difference between the Value added (current US$) in Turkmenistan in 2009 and the Value added (current US$) in United Arab Emirates in 2010?
Your answer should be compact. -8.77e+06. What is the difference between the Value added (current US$) in Grenada in 2009 and the Value added (current US$) in Thailand in 2011?
Provide a short and direct response. -4.30e+1. What is the difference between the Value added (current US$) in Grenada in 2009 and the Value added (current US$) in Turkmenistan in 2011?
Offer a terse response. -3.99e+09. What is the difference between the Value added (current US$) in Grenada in 2009 and the Value added (current US$) in United Arab Emirates in 2011?
Make the answer very short. -2.51e+09. What is the difference between the Value added (current US$) in Thailand in 2009 and the Value added (current US$) in Turkmenistan in 2011?
Give a very brief answer. 2.36e+1. What is the difference between the Value added (current US$) of Thailand in 2009 and the Value added (current US$) of United Arab Emirates in 2011?
Offer a very short reply. 2.50e+1. What is the difference between the Value added (current US$) of Turkmenistan in 2009 and the Value added (current US$) of United Arab Emirates in 2011?
Your answer should be very brief. -1.07e+08. What is the difference between the Value added (current US$) in Grenada in 2009 and the Value added (current US$) in Thailand in 2012?
Offer a terse response. -4.59e+1. What is the difference between the Value added (current US$) in Grenada in 2009 and the Value added (current US$) in Turkmenistan in 2012?
Provide a short and direct response. -4.92e+09. What is the difference between the Value added (current US$) of Grenada in 2009 and the Value added (current US$) of United Arab Emirates in 2012?
Provide a succinct answer. -2.55e+09. What is the difference between the Value added (current US$) of Thailand in 2009 and the Value added (current US$) of Turkmenistan in 2012?
Your response must be concise. 2.26e+1. What is the difference between the Value added (current US$) of Thailand in 2009 and the Value added (current US$) of United Arab Emirates in 2012?
Provide a succinct answer. 2.50e+1. What is the difference between the Value added (current US$) of Turkmenistan in 2009 and the Value added (current US$) of United Arab Emirates in 2012?
Keep it short and to the point. -1.42e+08. What is the difference between the Value added (current US$) of Grenada in 2010 and the Value added (current US$) of Thailand in 2011?
Keep it short and to the point. -4.30e+1. What is the difference between the Value added (current US$) of Grenada in 2010 and the Value added (current US$) of Turkmenistan in 2011?
Make the answer very short. -3.99e+09. What is the difference between the Value added (current US$) of Grenada in 2010 and the Value added (current US$) of United Arab Emirates in 2011?
Your response must be concise. -2.51e+09. What is the difference between the Value added (current US$) in Thailand in 2010 and the Value added (current US$) in Turkmenistan in 2011?
Your answer should be very brief. 3.19e+1. What is the difference between the Value added (current US$) in Thailand in 2010 and the Value added (current US$) in United Arab Emirates in 2011?
Your answer should be compact. 3.34e+1. What is the difference between the Value added (current US$) in Turkmenistan in 2010 and the Value added (current US$) in United Arab Emirates in 2011?
Keep it short and to the point. 6.30e+08. What is the difference between the Value added (current US$) of Grenada in 2010 and the Value added (current US$) of Thailand in 2012?
Provide a short and direct response. -4.60e+1. What is the difference between the Value added (current US$) in Grenada in 2010 and the Value added (current US$) in Turkmenistan in 2012?
Ensure brevity in your answer.  -4.92e+09. What is the difference between the Value added (current US$) in Grenada in 2010 and the Value added (current US$) in United Arab Emirates in 2012?
Your response must be concise. -2.55e+09. What is the difference between the Value added (current US$) of Thailand in 2010 and the Value added (current US$) of Turkmenistan in 2012?
Provide a succinct answer. 3.09e+1. What is the difference between the Value added (current US$) of Thailand in 2010 and the Value added (current US$) of United Arab Emirates in 2012?
Offer a terse response. 3.33e+1. What is the difference between the Value added (current US$) of Turkmenistan in 2010 and the Value added (current US$) of United Arab Emirates in 2012?
Keep it short and to the point. 5.95e+08. What is the difference between the Value added (current US$) in Grenada in 2011 and the Value added (current US$) in Thailand in 2012?
Give a very brief answer. -4.60e+1. What is the difference between the Value added (current US$) of Grenada in 2011 and the Value added (current US$) of Turkmenistan in 2012?
Provide a succinct answer. -4.92e+09. What is the difference between the Value added (current US$) of Grenada in 2011 and the Value added (current US$) of United Arab Emirates in 2012?
Offer a very short reply. -2.55e+09. What is the difference between the Value added (current US$) of Thailand in 2011 and the Value added (current US$) of Turkmenistan in 2012?
Your response must be concise. 3.80e+1. What is the difference between the Value added (current US$) of Thailand in 2011 and the Value added (current US$) of United Arab Emirates in 2012?
Make the answer very short. 4.04e+1. What is the difference between the Value added (current US$) of Turkmenistan in 2011 and the Value added (current US$) of United Arab Emirates in 2012?
Your answer should be compact. 1.44e+09. What is the average Value added (current US$) of Grenada per year?
Provide a short and direct response. 3.12e+07. What is the average Value added (current US$) in Thailand per year?
Keep it short and to the point. 3.06e+1. What is the average Value added (current US$) of Turkmenistan per year?
Your answer should be compact. 2.82e+09. What is the average Value added (current US$) in United Arab Emirates per year?
Ensure brevity in your answer.  2.54e+09. In the year 2005, what is the difference between the Value added (current US$) in Grenada and Value added (current US$) in Thailand?
Provide a succinct answer. -1.74e+1. In the year 2005, what is the difference between the Value added (current US$) of Grenada and Value added (current US$) of Turkmenistan?
Make the answer very short. -1.48e+09. In the year 2005, what is the difference between the Value added (current US$) of Grenada and Value added (current US$) of United Arab Emirates?
Your response must be concise. -2.50e+09. In the year 2005, what is the difference between the Value added (current US$) of Thailand and Value added (current US$) of Turkmenistan?
Offer a very short reply. 1.59e+1. In the year 2005, what is the difference between the Value added (current US$) in Thailand and Value added (current US$) in United Arab Emirates?
Provide a succinct answer. 1.49e+1. In the year 2005, what is the difference between the Value added (current US$) in Turkmenistan and Value added (current US$) in United Arab Emirates?
Give a very brief answer. -1.02e+09. In the year 2006, what is the difference between the Value added (current US$) of Grenada and Value added (current US$) of Thailand?
Your answer should be compact. -2.08e+1. In the year 2006, what is the difference between the Value added (current US$) in Grenada and Value added (current US$) in Turkmenistan?
Your answer should be very brief. -1.74e+09. In the year 2006, what is the difference between the Value added (current US$) in Grenada and Value added (current US$) in United Arab Emirates?
Offer a very short reply. -2.40e+09. In the year 2006, what is the difference between the Value added (current US$) in Thailand and Value added (current US$) in Turkmenistan?
Your response must be concise. 1.91e+1. In the year 2006, what is the difference between the Value added (current US$) of Thailand and Value added (current US$) of United Arab Emirates?
Offer a very short reply. 1.84e+1. In the year 2006, what is the difference between the Value added (current US$) of Turkmenistan and Value added (current US$) of United Arab Emirates?
Offer a very short reply. -6.63e+08. In the year 2007, what is the difference between the Value added (current US$) in Grenada and Value added (current US$) in Thailand?
Give a very brief answer. -2.46e+1. In the year 2007, what is the difference between the Value added (current US$) in Grenada and Value added (current US$) in Turkmenistan?
Keep it short and to the point. -2.36e+09. In the year 2007, what is the difference between the Value added (current US$) in Grenada and Value added (current US$) in United Arab Emirates?
Ensure brevity in your answer.  -2.49e+09. In the year 2007, what is the difference between the Value added (current US$) of Thailand and Value added (current US$) of Turkmenistan?
Offer a very short reply. 2.22e+1. In the year 2007, what is the difference between the Value added (current US$) of Thailand and Value added (current US$) of United Arab Emirates?
Your answer should be very brief. 2.21e+1. In the year 2007, what is the difference between the Value added (current US$) of Turkmenistan and Value added (current US$) of United Arab Emirates?
Offer a terse response. -1.31e+08. In the year 2008, what is the difference between the Value added (current US$) of Grenada and Value added (current US$) of Thailand?
Provide a succinct answer. -2.93e+1. In the year 2008, what is the difference between the Value added (current US$) of Grenada and Value added (current US$) of Turkmenistan?
Keep it short and to the point. -2.30e+09. In the year 2008, what is the difference between the Value added (current US$) of Grenada and Value added (current US$) of United Arab Emirates?
Your response must be concise. -2.58e+09. In the year 2008, what is the difference between the Value added (current US$) of Thailand and Value added (current US$) of Turkmenistan?
Your answer should be very brief. 2.70e+1. In the year 2008, what is the difference between the Value added (current US$) in Thailand and Value added (current US$) in United Arab Emirates?
Provide a succinct answer. 2.67e+1. In the year 2008, what is the difference between the Value added (current US$) of Turkmenistan and Value added (current US$) of United Arab Emirates?
Provide a succinct answer. -2.77e+08. In the year 2009, what is the difference between the Value added (current US$) in Grenada and Value added (current US$) in Thailand?
Offer a very short reply. -2.75e+1. In the year 2009, what is the difference between the Value added (current US$) in Grenada and Value added (current US$) in Turkmenistan?
Your response must be concise. -2.40e+09. In the year 2009, what is the difference between the Value added (current US$) in Grenada and Value added (current US$) in United Arab Emirates?
Provide a succinct answer. -2.59e+09. In the year 2009, what is the difference between the Value added (current US$) in Thailand and Value added (current US$) in Turkmenistan?
Provide a succinct answer. 2.51e+1. In the year 2009, what is the difference between the Value added (current US$) in Thailand and Value added (current US$) in United Arab Emirates?
Make the answer very short. 2.50e+1. In the year 2009, what is the difference between the Value added (current US$) in Turkmenistan and Value added (current US$) in United Arab Emirates?
Your answer should be compact. -1.89e+08. In the year 2010, what is the difference between the Value added (current US$) in Grenada and Value added (current US$) in Thailand?
Make the answer very short. -3.59e+1. In the year 2010, what is the difference between the Value added (current US$) in Grenada and Value added (current US$) in Turkmenistan?
Make the answer very short. -3.14e+09. In the year 2010, what is the difference between the Value added (current US$) of Grenada and Value added (current US$) of United Arab Emirates?
Ensure brevity in your answer.  -2.41e+09. In the year 2010, what is the difference between the Value added (current US$) of Thailand and Value added (current US$) of Turkmenistan?
Your answer should be very brief. 3.27e+1. In the year 2010, what is the difference between the Value added (current US$) of Thailand and Value added (current US$) of United Arab Emirates?
Provide a short and direct response. 3.35e+1. In the year 2010, what is the difference between the Value added (current US$) of Turkmenistan and Value added (current US$) of United Arab Emirates?
Give a very brief answer. 7.28e+08. In the year 2011, what is the difference between the Value added (current US$) in Grenada and Value added (current US$) in Thailand?
Make the answer very short. -4.30e+1. In the year 2011, what is the difference between the Value added (current US$) of Grenada and Value added (current US$) of Turkmenistan?
Make the answer very short. -3.99e+09. In the year 2011, what is the difference between the Value added (current US$) of Grenada and Value added (current US$) of United Arab Emirates?
Provide a short and direct response. -2.51e+09. In the year 2011, what is the difference between the Value added (current US$) of Thailand and Value added (current US$) of Turkmenistan?
Ensure brevity in your answer.  3.90e+1. In the year 2011, what is the difference between the Value added (current US$) in Thailand and Value added (current US$) in United Arab Emirates?
Provide a short and direct response. 4.04e+1. In the year 2011, what is the difference between the Value added (current US$) in Turkmenistan and Value added (current US$) in United Arab Emirates?
Your answer should be compact. 1.48e+09. In the year 2012, what is the difference between the Value added (current US$) in Grenada and Value added (current US$) in Thailand?
Keep it short and to the point. -4.59e+1. In the year 2012, what is the difference between the Value added (current US$) of Grenada and Value added (current US$) of Turkmenistan?
Offer a terse response. -4.92e+09. In the year 2012, what is the difference between the Value added (current US$) of Grenada and Value added (current US$) of United Arab Emirates?
Provide a succinct answer. -2.54e+09. In the year 2012, what is the difference between the Value added (current US$) in Thailand and Value added (current US$) in Turkmenistan?
Give a very brief answer. 4.10e+1. In the year 2012, what is the difference between the Value added (current US$) of Thailand and Value added (current US$) of United Arab Emirates?
Make the answer very short. 4.34e+1. In the year 2012, what is the difference between the Value added (current US$) in Turkmenistan and Value added (current US$) in United Arab Emirates?
Make the answer very short. 2.37e+09. What is the ratio of the Value added (current US$) in Grenada in 2005 to that in 2006?
Provide a short and direct response. 0.76. What is the ratio of the Value added (current US$) in Thailand in 2005 to that in 2006?
Offer a very short reply. 0.83. What is the ratio of the Value added (current US$) in Turkmenistan in 2005 to that in 2006?
Provide a short and direct response. 0.85. What is the ratio of the Value added (current US$) of Grenada in 2005 to that in 2007?
Ensure brevity in your answer.  0.76. What is the ratio of the Value added (current US$) of Thailand in 2005 to that in 2007?
Your answer should be compact. 0.71. What is the ratio of the Value added (current US$) in Turkmenistan in 2005 to that in 2007?
Give a very brief answer. 0.63. What is the ratio of the Value added (current US$) in Grenada in 2005 to that in 2008?
Offer a terse response. 0.66. What is the ratio of the Value added (current US$) of Thailand in 2005 to that in 2008?
Give a very brief answer. 0.59. What is the ratio of the Value added (current US$) in Turkmenistan in 2005 to that in 2008?
Provide a short and direct response. 0.64. What is the ratio of the Value added (current US$) in United Arab Emirates in 2005 to that in 2008?
Provide a succinct answer. 0.97. What is the ratio of the Value added (current US$) in Grenada in 2005 to that in 2009?
Keep it short and to the point. 0.58. What is the ratio of the Value added (current US$) of Thailand in 2005 to that in 2009?
Offer a very short reply. 0.63. What is the ratio of the Value added (current US$) in Turkmenistan in 2005 to that in 2009?
Your answer should be very brief. 0.62. What is the ratio of the Value added (current US$) of United Arab Emirates in 2005 to that in 2009?
Offer a very short reply. 0.96. What is the ratio of the Value added (current US$) in Grenada in 2005 to that in 2010?
Ensure brevity in your answer.  0.59. What is the ratio of the Value added (current US$) of Thailand in 2005 to that in 2010?
Offer a terse response. 0.48. What is the ratio of the Value added (current US$) in Turkmenistan in 2005 to that in 2010?
Offer a very short reply. 0.47. What is the ratio of the Value added (current US$) in United Arab Emirates in 2005 to that in 2010?
Offer a very short reply. 1.03. What is the ratio of the Value added (current US$) of Grenada in 2005 to that in 2011?
Keep it short and to the point. 0.6. What is the ratio of the Value added (current US$) of Thailand in 2005 to that in 2011?
Keep it short and to the point. 0.41. What is the ratio of the Value added (current US$) of Turkmenistan in 2005 to that in 2011?
Your response must be concise. 0.37. What is the ratio of the Value added (current US$) in Grenada in 2005 to that in 2012?
Offer a very short reply. 0.53. What is the ratio of the Value added (current US$) of Thailand in 2005 to that in 2012?
Make the answer very short. 0.38. What is the ratio of the Value added (current US$) of Turkmenistan in 2005 to that in 2012?
Give a very brief answer. 0.3. What is the ratio of the Value added (current US$) of United Arab Emirates in 2005 to that in 2012?
Ensure brevity in your answer.  0.98. What is the ratio of the Value added (current US$) of Grenada in 2006 to that in 2007?
Your response must be concise. 1.01. What is the ratio of the Value added (current US$) in Thailand in 2006 to that in 2007?
Provide a succinct answer. 0.85. What is the ratio of the Value added (current US$) of Turkmenistan in 2006 to that in 2007?
Offer a terse response. 0.74. What is the ratio of the Value added (current US$) of United Arab Emirates in 2006 to that in 2007?
Offer a very short reply. 0.96. What is the ratio of the Value added (current US$) of Grenada in 2006 to that in 2008?
Your answer should be very brief. 0.87. What is the ratio of the Value added (current US$) in Thailand in 2006 to that in 2008?
Offer a terse response. 0.71. What is the ratio of the Value added (current US$) of Turkmenistan in 2006 to that in 2008?
Give a very brief answer. 0.76. What is the ratio of the Value added (current US$) in United Arab Emirates in 2006 to that in 2008?
Your answer should be compact. 0.93. What is the ratio of the Value added (current US$) in Grenada in 2006 to that in 2009?
Your response must be concise. 0.76. What is the ratio of the Value added (current US$) in Thailand in 2006 to that in 2009?
Offer a very short reply. 0.76. What is the ratio of the Value added (current US$) in Turkmenistan in 2006 to that in 2009?
Your answer should be compact. 0.72. What is the ratio of the Value added (current US$) in United Arab Emirates in 2006 to that in 2009?
Ensure brevity in your answer.  0.92. What is the ratio of the Value added (current US$) of Grenada in 2006 to that in 2010?
Your answer should be very brief. 0.78. What is the ratio of the Value added (current US$) of Thailand in 2006 to that in 2010?
Your answer should be very brief. 0.58. What is the ratio of the Value added (current US$) in Turkmenistan in 2006 to that in 2010?
Make the answer very short. 0.56. What is the ratio of the Value added (current US$) of Grenada in 2006 to that in 2011?
Keep it short and to the point. 0.78. What is the ratio of the Value added (current US$) of Thailand in 2006 to that in 2011?
Your answer should be compact. 0.49. What is the ratio of the Value added (current US$) in Turkmenistan in 2006 to that in 2011?
Your answer should be very brief. 0.44. What is the ratio of the Value added (current US$) in United Arab Emirates in 2006 to that in 2011?
Offer a terse response. 0.95. What is the ratio of the Value added (current US$) in Grenada in 2006 to that in 2012?
Offer a terse response. 0.7. What is the ratio of the Value added (current US$) in Thailand in 2006 to that in 2012?
Offer a very short reply. 0.45. What is the ratio of the Value added (current US$) in Turkmenistan in 2006 to that in 2012?
Offer a terse response. 0.36. What is the ratio of the Value added (current US$) in United Arab Emirates in 2006 to that in 2012?
Offer a terse response. 0.94. What is the ratio of the Value added (current US$) of Grenada in 2007 to that in 2008?
Keep it short and to the point. 0.87. What is the ratio of the Value added (current US$) of Thailand in 2007 to that in 2008?
Provide a succinct answer. 0.84. What is the ratio of the Value added (current US$) of Turkmenistan in 2007 to that in 2008?
Provide a succinct answer. 1.02. What is the ratio of the Value added (current US$) of United Arab Emirates in 2007 to that in 2008?
Offer a very short reply. 0.97. What is the ratio of the Value added (current US$) in Grenada in 2007 to that in 2009?
Make the answer very short. 0.76. What is the ratio of the Value added (current US$) of Thailand in 2007 to that in 2009?
Offer a very short reply. 0.89. What is the ratio of the Value added (current US$) of Turkmenistan in 2007 to that in 2009?
Ensure brevity in your answer.  0.98. What is the ratio of the Value added (current US$) of United Arab Emirates in 2007 to that in 2009?
Offer a very short reply. 0.96. What is the ratio of the Value added (current US$) in Grenada in 2007 to that in 2010?
Offer a very short reply. 0.78. What is the ratio of the Value added (current US$) of Thailand in 2007 to that in 2010?
Your answer should be compact. 0.68. What is the ratio of the Value added (current US$) of Turkmenistan in 2007 to that in 2010?
Give a very brief answer. 0.75. What is the ratio of the Value added (current US$) of United Arab Emirates in 2007 to that in 2010?
Make the answer very short. 1.03. What is the ratio of the Value added (current US$) in Grenada in 2007 to that in 2011?
Provide a succinct answer. 0.78. What is the ratio of the Value added (current US$) of Thailand in 2007 to that in 2011?
Offer a very short reply. 0.57. What is the ratio of the Value added (current US$) of Turkmenistan in 2007 to that in 2011?
Offer a very short reply. 0.59. What is the ratio of the Value added (current US$) of Grenada in 2007 to that in 2012?
Offer a very short reply. 0.7. What is the ratio of the Value added (current US$) in Thailand in 2007 to that in 2012?
Your response must be concise. 0.53. What is the ratio of the Value added (current US$) in Turkmenistan in 2007 to that in 2012?
Offer a terse response. 0.48. What is the ratio of the Value added (current US$) in United Arab Emirates in 2007 to that in 2012?
Your response must be concise. 0.98. What is the ratio of the Value added (current US$) of Grenada in 2008 to that in 2009?
Offer a very short reply. 0.87. What is the ratio of the Value added (current US$) in Thailand in 2008 to that in 2009?
Keep it short and to the point. 1.06. What is the ratio of the Value added (current US$) in Turkmenistan in 2008 to that in 2009?
Provide a succinct answer. 0.96. What is the ratio of the Value added (current US$) in United Arab Emirates in 2008 to that in 2009?
Your answer should be compact. 0.99. What is the ratio of the Value added (current US$) of Grenada in 2008 to that in 2010?
Offer a terse response. 0.89. What is the ratio of the Value added (current US$) in Thailand in 2008 to that in 2010?
Offer a very short reply. 0.82. What is the ratio of the Value added (current US$) in Turkmenistan in 2008 to that in 2010?
Offer a very short reply. 0.73. What is the ratio of the Value added (current US$) in United Arab Emirates in 2008 to that in 2010?
Make the answer very short. 1.07. What is the ratio of the Value added (current US$) of Grenada in 2008 to that in 2011?
Make the answer very short. 0.9. What is the ratio of the Value added (current US$) of Thailand in 2008 to that in 2011?
Keep it short and to the point. 0.68. What is the ratio of the Value added (current US$) in Turkmenistan in 2008 to that in 2011?
Keep it short and to the point. 0.58. What is the ratio of the Value added (current US$) in United Arab Emirates in 2008 to that in 2011?
Ensure brevity in your answer.  1.02. What is the ratio of the Value added (current US$) of Grenada in 2008 to that in 2012?
Your response must be concise. 0.81. What is the ratio of the Value added (current US$) of Thailand in 2008 to that in 2012?
Provide a succinct answer. 0.64. What is the ratio of the Value added (current US$) in Turkmenistan in 2008 to that in 2012?
Offer a terse response. 0.47. What is the ratio of the Value added (current US$) in United Arab Emirates in 2008 to that in 2012?
Provide a succinct answer. 1.01. What is the ratio of the Value added (current US$) in Grenada in 2009 to that in 2010?
Provide a short and direct response. 1.03. What is the ratio of the Value added (current US$) in Thailand in 2009 to that in 2010?
Provide a short and direct response. 0.77. What is the ratio of the Value added (current US$) of Turkmenistan in 2009 to that in 2010?
Offer a very short reply. 0.77. What is the ratio of the Value added (current US$) in United Arab Emirates in 2009 to that in 2010?
Offer a terse response. 1.07. What is the ratio of the Value added (current US$) of Grenada in 2009 to that in 2011?
Your answer should be very brief. 1.03. What is the ratio of the Value added (current US$) of Thailand in 2009 to that in 2011?
Offer a terse response. 0.64. What is the ratio of the Value added (current US$) of Turkmenistan in 2009 to that in 2011?
Provide a short and direct response. 0.61. What is the ratio of the Value added (current US$) of United Arab Emirates in 2009 to that in 2011?
Offer a very short reply. 1.03. What is the ratio of the Value added (current US$) in Grenada in 2009 to that in 2012?
Your answer should be compact. 0.92. What is the ratio of the Value added (current US$) in Thailand in 2009 to that in 2012?
Your answer should be compact. 0.6. What is the ratio of the Value added (current US$) of Turkmenistan in 2009 to that in 2012?
Your response must be concise. 0.49. What is the ratio of the Value added (current US$) in United Arab Emirates in 2009 to that in 2012?
Ensure brevity in your answer.  1.02. What is the ratio of the Value added (current US$) in Grenada in 2010 to that in 2011?
Offer a very short reply. 1. What is the ratio of the Value added (current US$) of Thailand in 2010 to that in 2011?
Keep it short and to the point. 0.83. What is the ratio of the Value added (current US$) in Turkmenistan in 2010 to that in 2011?
Make the answer very short. 0.79. What is the ratio of the Value added (current US$) in United Arab Emirates in 2010 to that in 2011?
Offer a very short reply. 0.96. What is the ratio of the Value added (current US$) of Grenada in 2010 to that in 2012?
Ensure brevity in your answer.  0.9. What is the ratio of the Value added (current US$) in Thailand in 2010 to that in 2012?
Offer a terse response. 0.78. What is the ratio of the Value added (current US$) of Turkmenistan in 2010 to that in 2012?
Make the answer very short. 0.64. What is the ratio of the Value added (current US$) in United Arab Emirates in 2010 to that in 2012?
Your response must be concise. 0.95. What is the ratio of the Value added (current US$) in Grenada in 2011 to that in 2012?
Your answer should be compact. 0.9. What is the ratio of the Value added (current US$) in Thailand in 2011 to that in 2012?
Your answer should be compact. 0.94. What is the ratio of the Value added (current US$) in Turkmenistan in 2011 to that in 2012?
Make the answer very short. 0.81. What is the ratio of the Value added (current US$) of United Arab Emirates in 2011 to that in 2012?
Your answer should be compact. 0.99. What is the difference between the highest and the second highest Value added (current US$) of Grenada?
Keep it short and to the point. 2.97e+06. What is the difference between the highest and the second highest Value added (current US$) of Thailand?
Your answer should be compact. 2.99e+09. What is the difference between the highest and the second highest Value added (current US$) of Turkmenistan?
Your answer should be compact. 9.29e+08. What is the difference between the highest and the second highest Value added (current US$) of United Arab Emirates?
Make the answer very short. 1.91e+07. What is the difference between the highest and the lowest Value added (current US$) in Grenada?
Give a very brief answer. 1.80e+07. What is the difference between the highest and the lowest Value added (current US$) in Thailand?
Keep it short and to the point. 2.86e+1. What is the difference between the highest and the lowest Value added (current US$) in Turkmenistan?
Give a very brief answer. 3.45e+09. What is the difference between the highest and the lowest Value added (current US$) of United Arab Emirates?
Your answer should be very brief. 1.99e+08. 